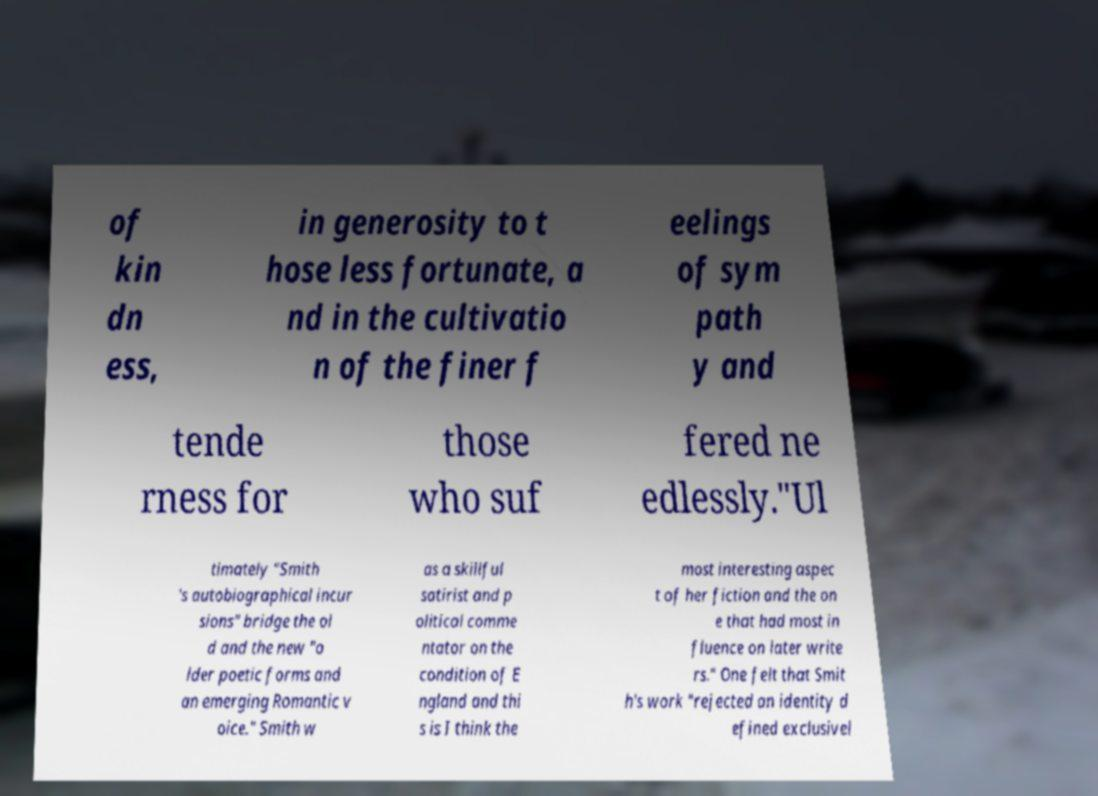Could you assist in decoding the text presented in this image and type it out clearly? of kin dn ess, in generosity to t hose less fortunate, a nd in the cultivatio n of the finer f eelings of sym path y and tende rness for those who suf fered ne edlessly."Ul timately "Smith 's autobiographical incur sions" bridge the ol d and the new "o lder poetic forms and an emerging Romantic v oice." Smith w as a skillful satirist and p olitical comme ntator on the condition of E ngland and thi s is I think the most interesting aspec t of her fiction and the on e that had most in fluence on later write rs." One felt that Smit h's work "rejected an identity d efined exclusivel 